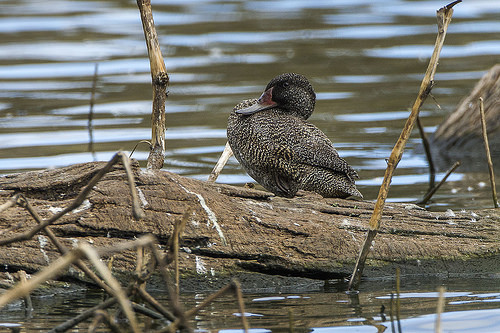<image>
Can you confirm if the bird is behind the water? Yes. From this viewpoint, the bird is positioned behind the water, with the water partially or fully occluding the bird. Where is the bird in relation to the tree? Is it behind the tree? Yes. From this viewpoint, the bird is positioned behind the tree, with the tree partially or fully occluding the bird. 